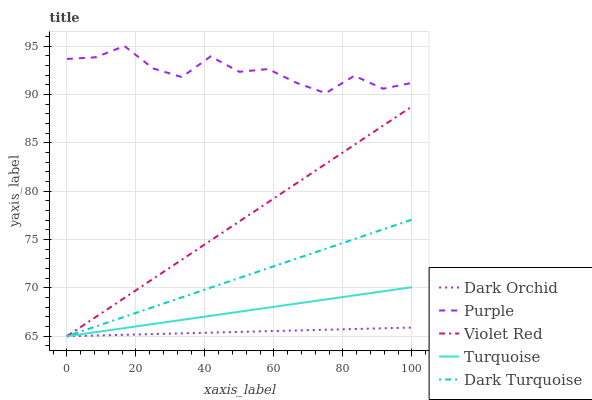Does Dark Orchid have the minimum area under the curve?
Answer yes or no. Yes. Does Purple have the maximum area under the curve?
Answer yes or no. Yes. Does Dark Turquoise have the minimum area under the curve?
Answer yes or no. No. Does Dark Turquoise have the maximum area under the curve?
Answer yes or no. No. Is Dark Orchid the smoothest?
Answer yes or no. Yes. Is Purple the roughest?
Answer yes or no. Yes. Is Dark Turquoise the smoothest?
Answer yes or no. No. Is Dark Turquoise the roughest?
Answer yes or no. No. Does Dark Turquoise have the lowest value?
Answer yes or no. Yes. Does Purple have the highest value?
Answer yes or no. Yes. Does Dark Turquoise have the highest value?
Answer yes or no. No. Is Turquoise less than Purple?
Answer yes or no. Yes. Is Purple greater than Turquoise?
Answer yes or no. Yes. Does Violet Red intersect Turquoise?
Answer yes or no. Yes. Is Violet Red less than Turquoise?
Answer yes or no. No. Is Violet Red greater than Turquoise?
Answer yes or no. No. Does Turquoise intersect Purple?
Answer yes or no. No. 